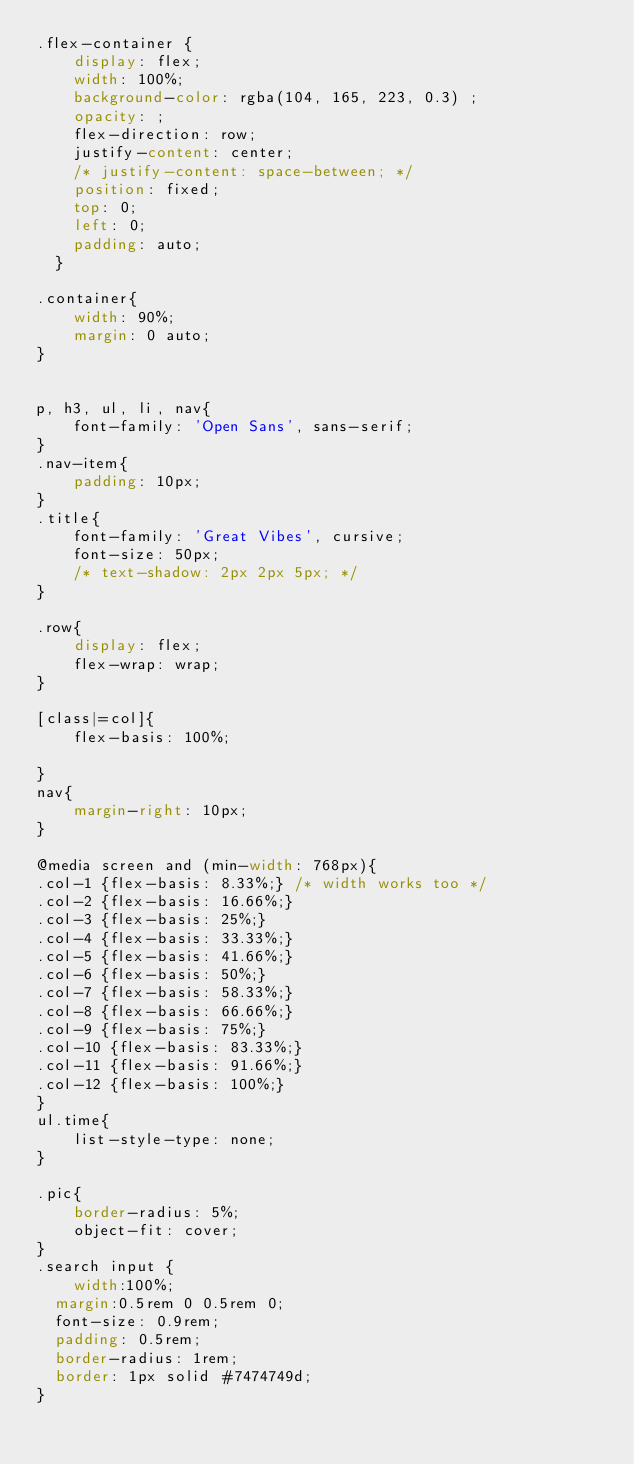Convert code to text. <code><loc_0><loc_0><loc_500><loc_500><_CSS_>.flex-container {
    display: flex;
    width: 100%;
    background-color: rgba(104, 165, 223, 0.3) ;
    opacity: ;
    flex-direction: row; 
    justify-content: center; 
    /* justify-content: space-between; */
    position: fixed;
    top: 0;
    left: 0;
    padding: auto;
  }

.container{
    width: 90%;
    margin: 0 auto;
}


p, h3, ul, li, nav{
    font-family: 'Open Sans', sans-serif;
}
.nav-item{
    padding: 10px;
}
.title{
    font-family: 'Great Vibes', cursive;
    font-size: 50px;
    /* text-shadow: 2px 2px 5px; */
}

.row{
	display: flex;	
    flex-wrap: wrap;
}

[class|=col]{
    flex-basis: 100%;

}
nav{
    margin-right: 10px;
}

@media screen and (min-width: 768px){
.col-1 {flex-basis: 8.33%;} /* width works too */
.col-2 {flex-basis: 16.66%;}
.col-3 {flex-basis: 25%;}
.col-4 {flex-basis: 33.33%;}
.col-5 {flex-basis: 41.66%;}
.col-6 {flex-basis: 50%;}
.col-7 {flex-basis: 58.33%;}
.col-8 {flex-basis: 66.66%;}
.col-9 {flex-basis: 75%;}
.col-10 {flex-basis: 83.33%;}
.col-11 {flex-basis: 91.66%;}
.col-12 {flex-basis: 100%;}
}
ul.time{
    list-style-type: none;
}

.pic{
    border-radius: 5%;
    object-fit: cover;
}
.search input {
	width:100%;
  margin:0.5rem 0 0.5rem 0;
  font-size: 0.9rem;
  padding: 0.5rem;
  border-radius: 1rem;
  border: 1px solid #7474749d;
}</code> 